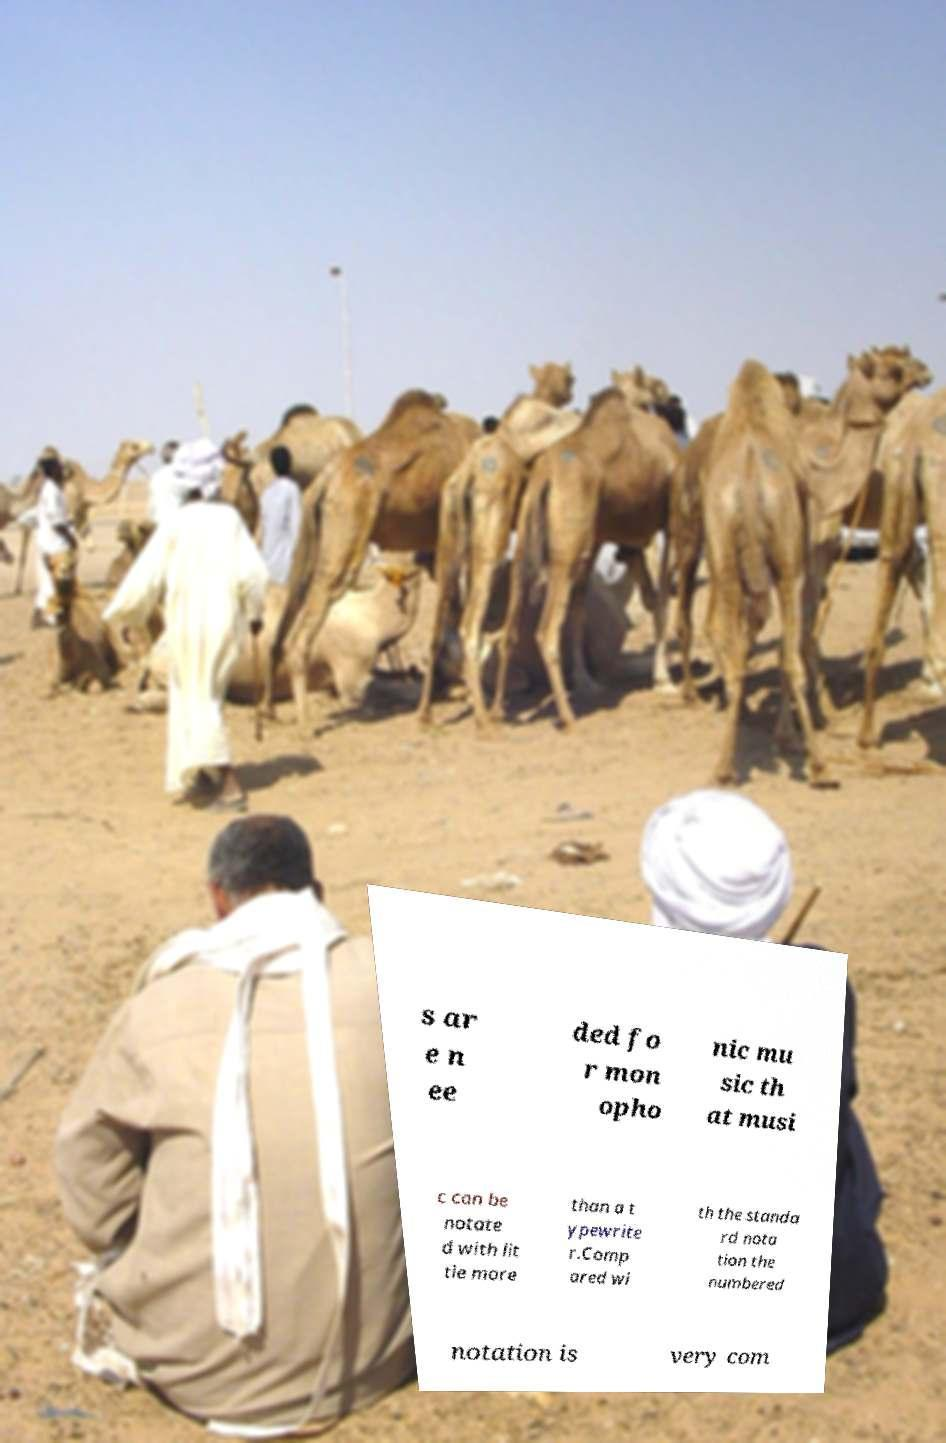Can you read and provide the text displayed in the image?This photo seems to have some interesting text. Can you extract and type it out for me? s ar e n ee ded fo r mon opho nic mu sic th at musi c can be notate d with lit tle more than a t ypewrite r.Comp ared wi th the standa rd nota tion the numbered notation is very com 